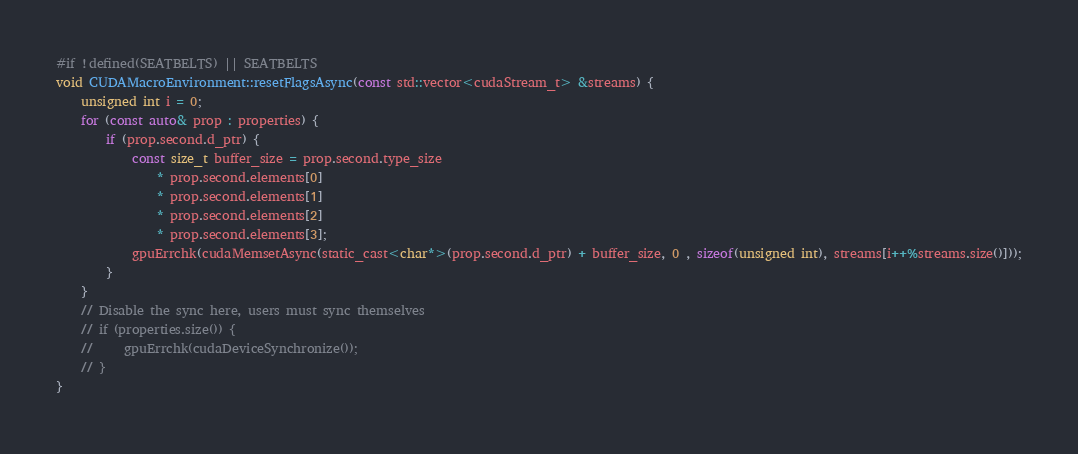Convert code to text. <code><loc_0><loc_0><loc_500><loc_500><_Cuda_>#if !defined(SEATBELTS) || SEATBELTS
void CUDAMacroEnvironment::resetFlagsAsync(const std::vector<cudaStream_t> &streams) {
    unsigned int i = 0;
    for (const auto& prop : properties) {
        if (prop.second.d_ptr) {
            const size_t buffer_size = prop.second.type_size
                * prop.second.elements[0]
                * prop.second.elements[1]
                * prop.second.elements[2]
                * prop.second.elements[3];
            gpuErrchk(cudaMemsetAsync(static_cast<char*>(prop.second.d_ptr) + buffer_size, 0 , sizeof(unsigned int), streams[i++%streams.size()]));
        }
    }
    // Disable the sync here, users must sync themselves
    // if (properties.size()) {
    //     gpuErrchk(cudaDeviceSynchronize());
    // }
}</code> 